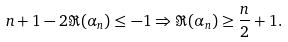<formula> <loc_0><loc_0><loc_500><loc_500>n + 1 - 2 \Re ( \alpha _ { n } ) \leq - 1 \Rightarrow \Re ( \alpha _ { n } ) \geq \frac { n } { 2 } + 1 .</formula> 